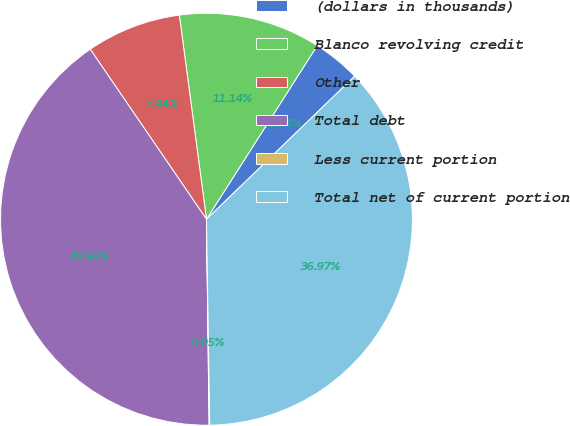<chart> <loc_0><loc_0><loc_500><loc_500><pie_chart><fcel>(dollars in thousands)<fcel>Blanco revolving credit<fcel>Other<fcel>Total debt<fcel>Less current portion<fcel>Total net of current portion<nl><fcel>3.74%<fcel>11.14%<fcel>7.44%<fcel>40.66%<fcel>0.05%<fcel>36.97%<nl></chart> 